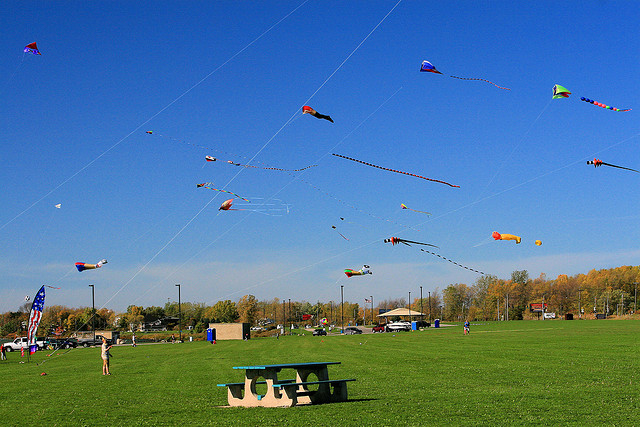<image>What color are the cars? I don't know the specific color of the cars. It could be white, silver, black, red, gray, blue or different colors. What color are the cars? I am not sure what color are the cars. There can be cars in white, silver, black, red, gray, and blue. 